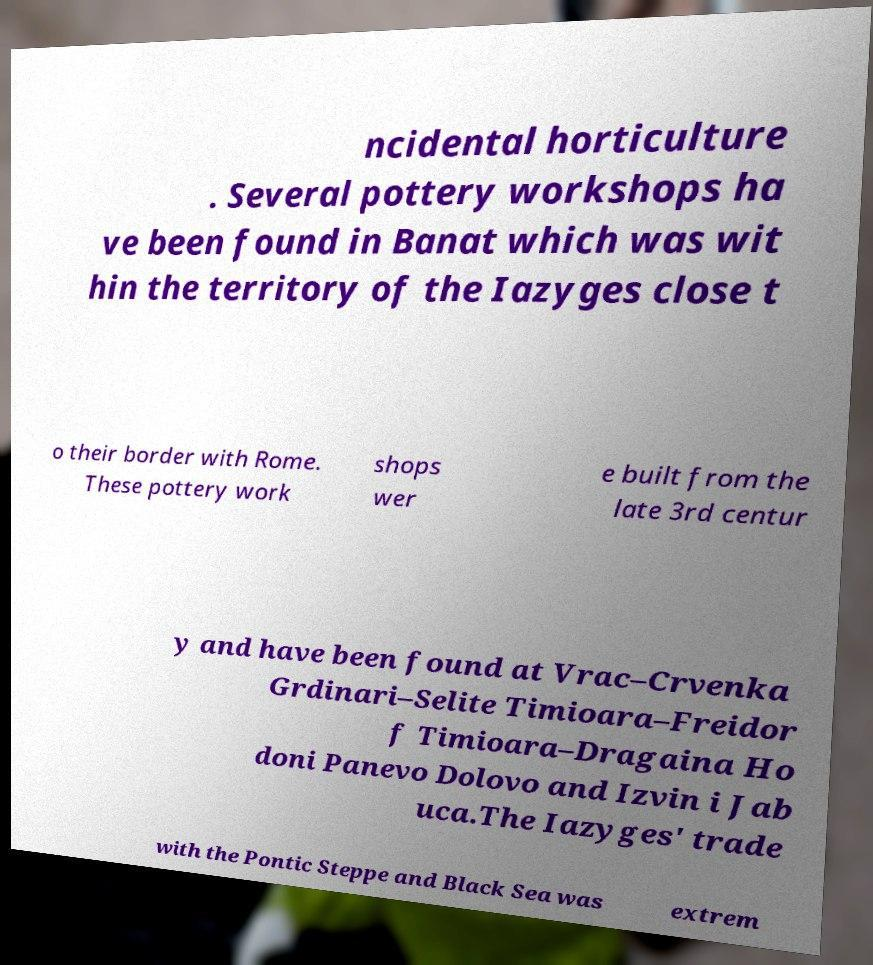Please read and relay the text visible in this image. What does it say? ncidental horticulture . Several pottery workshops ha ve been found in Banat which was wit hin the territory of the Iazyges close t o their border with Rome. These pottery work shops wer e built from the late 3rd centur y and have been found at Vrac–Crvenka Grdinari–Selite Timioara–Freidor f Timioara–Dragaina Ho doni Panevo Dolovo and Izvin i Jab uca.The Iazyges' trade with the Pontic Steppe and Black Sea was extrem 